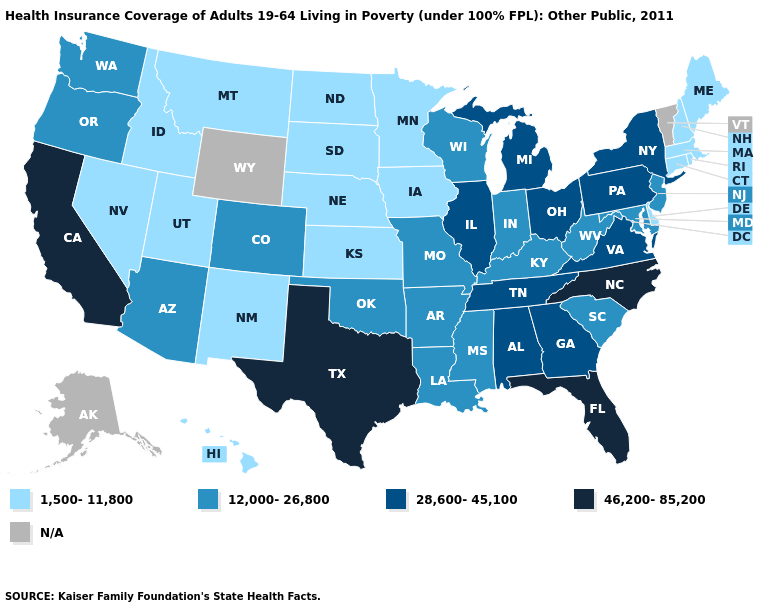Which states hav the highest value in the West?
Be succinct. California. What is the value of Maryland?
Write a very short answer. 12,000-26,800. What is the value of Michigan?
Be succinct. 28,600-45,100. Name the states that have a value in the range 46,200-85,200?
Quick response, please. California, Florida, North Carolina, Texas. Name the states that have a value in the range 12,000-26,800?
Quick response, please. Arizona, Arkansas, Colorado, Indiana, Kentucky, Louisiana, Maryland, Mississippi, Missouri, New Jersey, Oklahoma, Oregon, South Carolina, Washington, West Virginia, Wisconsin. Name the states that have a value in the range 1,500-11,800?
Answer briefly. Connecticut, Delaware, Hawaii, Idaho, Iowa, Kansas, Maine, Massachusetts, Minnesota, Montana, Nebraska, Nevada, New Hampshire, New Mexico, North Dakota, Rhode Island, South Dakota, Utah. Name the states that have a value in the range 46,200-85,200?
Be succinct. California, Florida, North Carolina, Texas. Name the states that have a value in the range 1,500-11,800?
Keep it brief. Connecticut, Delaware, Hawaii, Idaho, Iowa, Kansas, Maine, Massachusetts, Minnesota, Montana, Nebraska, Nevada, New Hampshire, New Mexico, North Dakota, Rhode Island, South Dakota, Utah. Among the states that border Connecticut , which have the lowest value?
Keep it brief. Massachusetts, Rhode Island. Name the states that have a value in the range 28,600-45,100?
Write a very short answer. Alabama, Georgia, Illinois, Michigan, New York, Ohio, Pennsylvania, Tennessee, Virginia. Does the first symbol in the legend represent the smallest category?
Short answer required. Yes. What is the lowest value in the West?
Be succinct. 1,500-11,800. Does Montana have the lowest value in the West?
Short answer required. Yes. How many symbols are there in the legend?
Keep it brief. 5. How many symbols are there in the legend?
Write a very short answer. 5. 